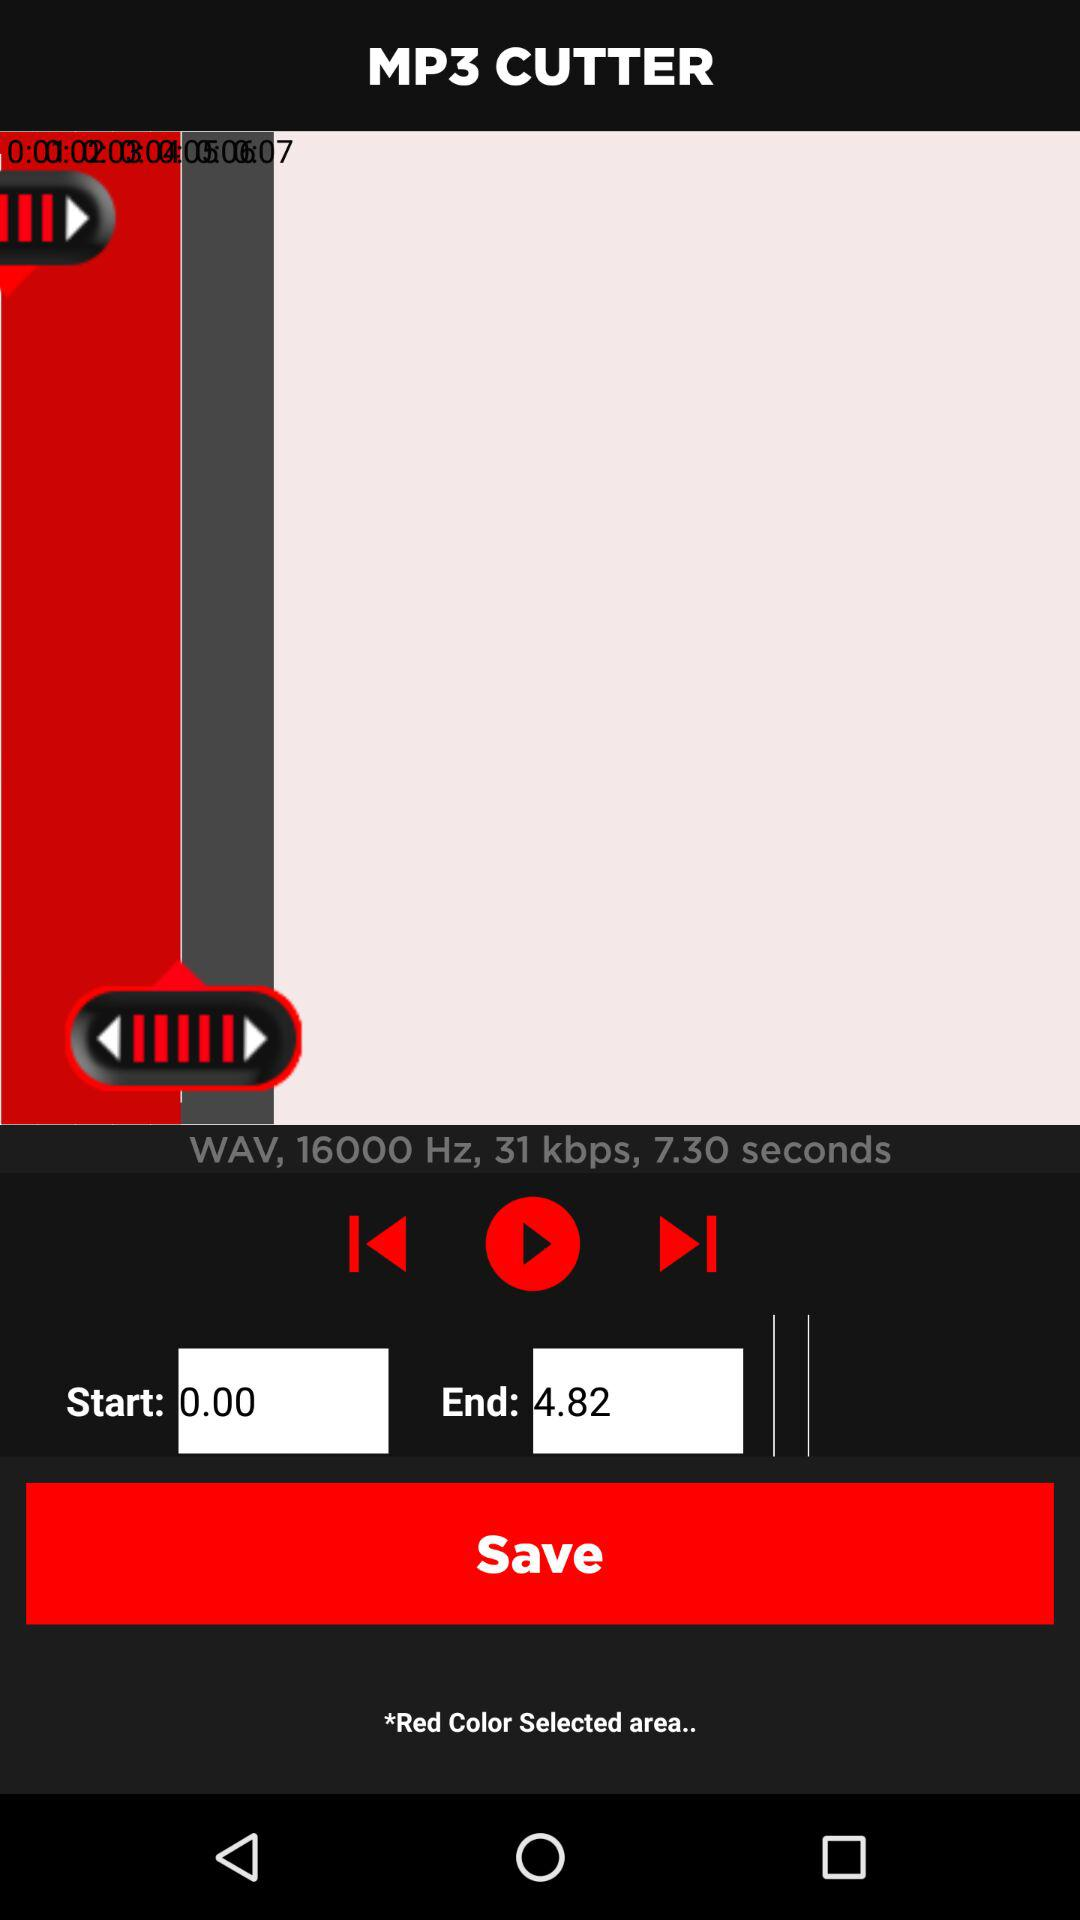What is the mentioned frequency in Hz? The mentioned frequency is 16000 Hz. 